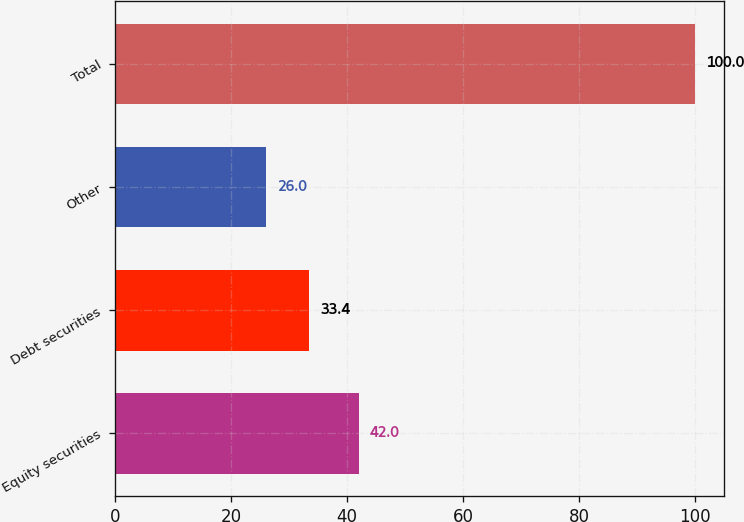Convert chart. <chart><loc_0><loc_0><loc_500><loc_500><bar_chart><fcel>Equity securities<fcel>Debt securities<fcel>Other<fcel>Total<nl><fcel>42<fcel>33.4<fcel>26<fcel>100<nl></chart> 